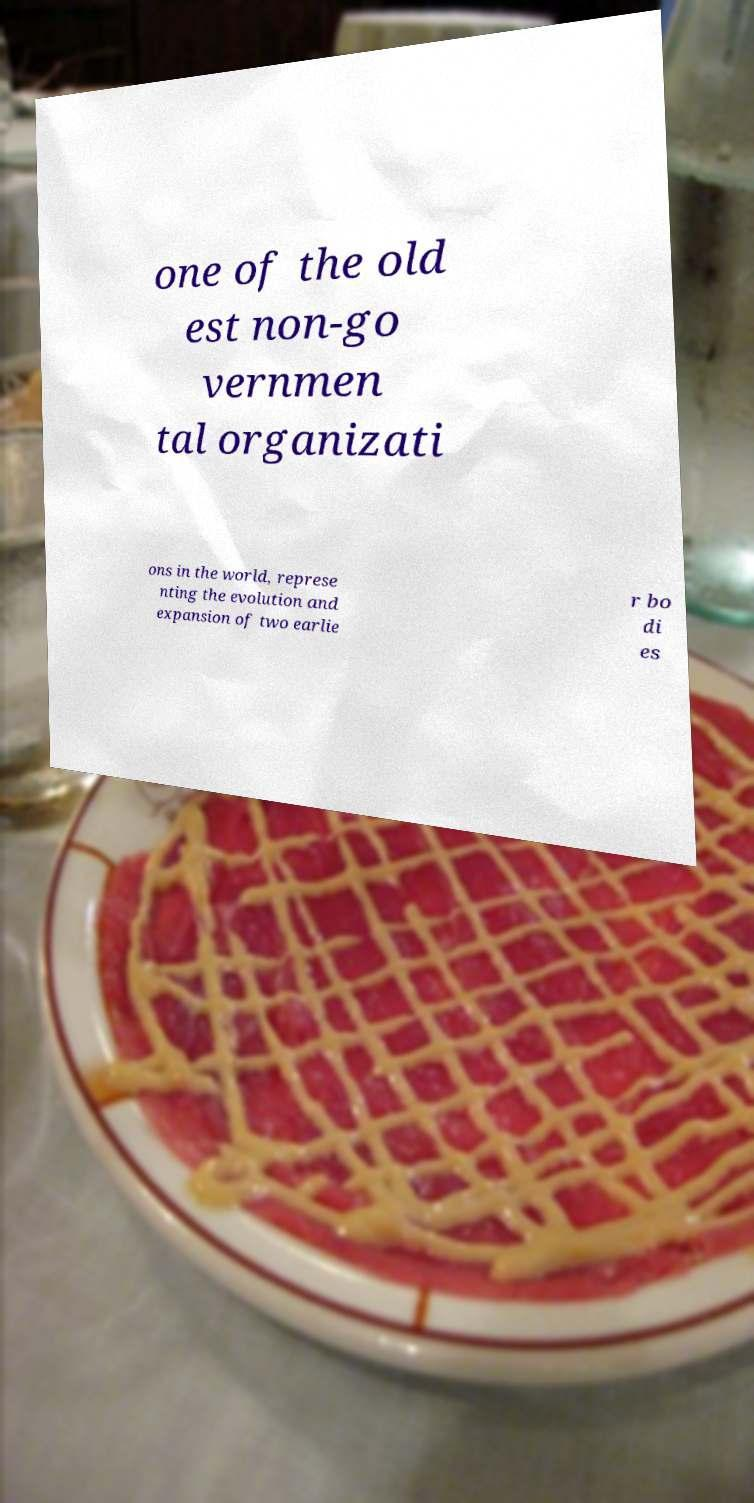I need the written content from this picture converted into text. Can you do that? one of the old est non-go vernmen tal organizati ons in the world, represe nting the evolution and expansion of two earlie r bo di es 